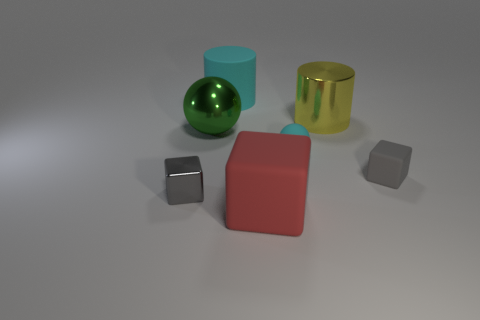Subtract all metal blocks. How many blocks are left? 2 Subtract all red blocks. How many blocks are left? 2 Subtract 3 cubes. How many cubes are left? 0 Add 3 large shiny cylinders. How many objects exist? 10 Subtract all cubes. How many objects are left? 4 Subtract all red spheres. How many gray blocks are left? 2 Subtract 0 red balls. How many objects are left? 7 Subtract all purple cubes. Subtract all yellow balls. How many cubes are left? 3 Subtract all yellow balls. Subtract all large rubber blocks. How many objects are left? 6 Add 7 big matte cylinders. How many big matte cylinders are left? 8 